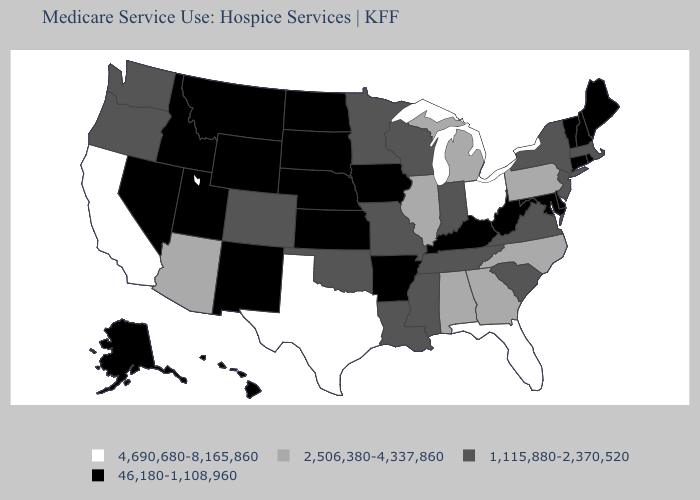What is the value of Hawaii?
Write a very short answer. 46,180-1,108,960. Name the states that have a value in the range 2,506,380-4,337,860?
Be succinct. Alabama, Arizona, Georgia, Illinois, Michigan, North Carolina, Pennsylvania. Name the states that have a value in the range 1,115,880-2,370,520?
Quick response, please. Colorado, Indiana, Louisiana, Massachusetts, Minnesota, Mississippi, Missouri, New Jersey, New York, Oklahoma, Oregon, South Carolina, Tennessee, Virginia, Washington, Wisconsin. Which states hav the highest value in the South?
Be succinct. Florida, Texas. How many symbols are there in the legend?
Answer briefly. 4. Is the legend a continuous bar?
Short answer required. No. What is the value of Oregon?
Keep it brief. 1,115,880-2,370,520. What is the lowest value in the USA?
Keep it brief. 46,180-1,108,960. Name the states that have a value in the range 46,180-1,108,960?
Short answer required. Alaska, Arkansas, Connecticut, Delaware, Hawaii, Idaho, Iowa, Kansas, Kentucky, Maine, Maryland, Montana, Nebraska, Nevada, New Hampshire, New Mexico, North Dakota, Rhode Island, South Dakota, Utah, Vermont, West Virginia, Wyoming. Name the states that have a value in the range 46,180-1,108,960?
Quick response, please. Alaska, Arkansas, Connecticut, Delaware, Hawaii, Idaho, Iowa, Kansas, Kentucky, Maine, Maryland, Montana, Nebraska, Nevada, New Hampshire, New Mexico, North Dakota, Rhode Island, South Dakota, Utah, Vermont, West Virginia, Wyoming. What is the value of Colorado?
Give a very brief answer. 1,115,880-2,370,520. What is the highest value in the MidWest ?
Short answer required. 4,690,680-8,165,860. Name the states that have a value in the range 4,690,680-8,165,860?
Give a very brief answer. California, Florida, Ohio, Texas. Which states hav the highest value in the West?
Concise answer only. California. 